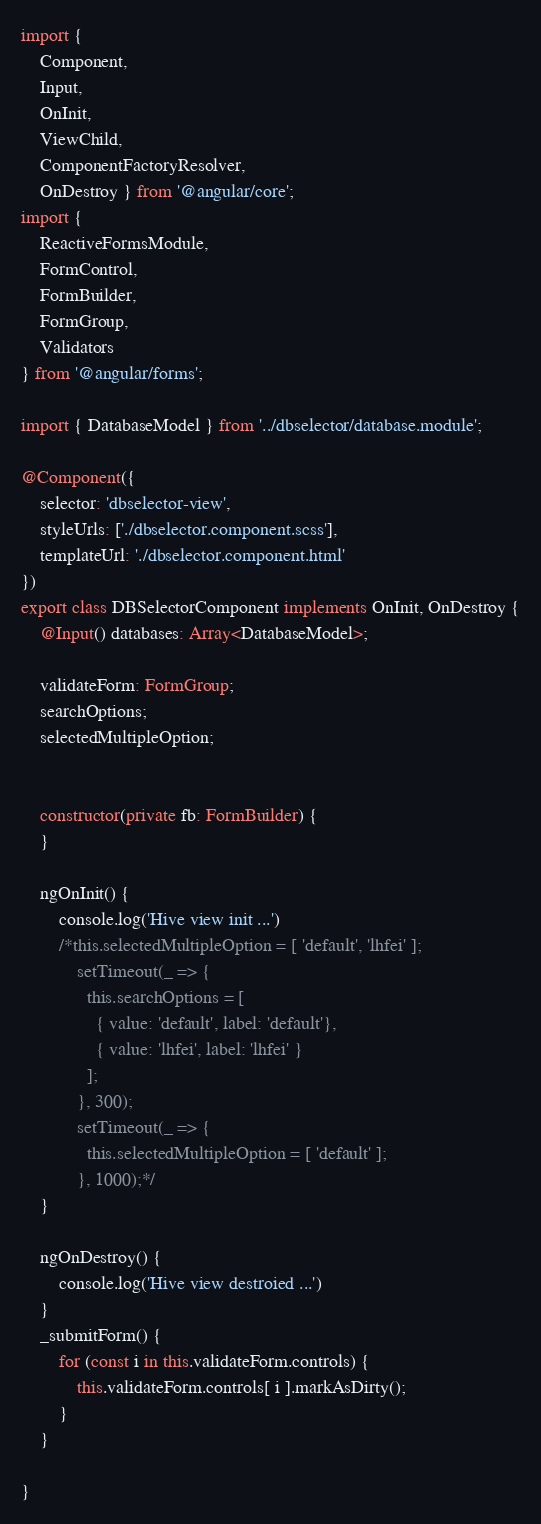<code> <loc_0><loc_0><loc_500><loc_500><_TypeScript_>import { 
	Component, 
	Input, 
	OnInit, 
	ViewChild, 
	ComponentFactoryResolver, 
	OnDestroy } from '@angular/core';
import {
	ReactiveFormsModule,
	FormControl,
	FormBuilder,
	FormGroup,
	Validators
} from '@angular/forms';

import { DatabaseModel } from '../dbselector/database.module';

@Component({
	selector: 'dbselector-view',
	styleUrls: ['./dbselector.component.scss'],
	templateUrl: './dbselector.component.html'
})
export class DBSelectorComponent implements OnInit, OnDestroy {
	@Input() databases: Array<DatabaseModel>;
	
	validateForm: FormGroup;
	searchOptions;
  	selectedMultipleOption;
  	

	constructor(private fb: FormBuilder) {
	}

	ngOnInit() {
		console.log('Hive view init ...')
		/*this.selectedMultipleOption = [ 'default', 'lhfei' ];
		    setTimeout(_ => {
		      this.searchOptions = [
		        { value: 'default', label: 'default'},
		        { value: 'lhfei', label: 'lhfei' }
		      ];
		    }, 300);
		    setTimeout(_ => {
		      this.selectedMultipleOption = [ 'default' ];
		    }, 1000);*/
	}

	ngOnDestroy() {
		console.log('Hive view destroied ...')
	}
	_submitForm() {
		for (const i in this.validateForm.controls) {
			this.validateForm.controls[ i ].markAsDirty();
		}
	}

}</code> 